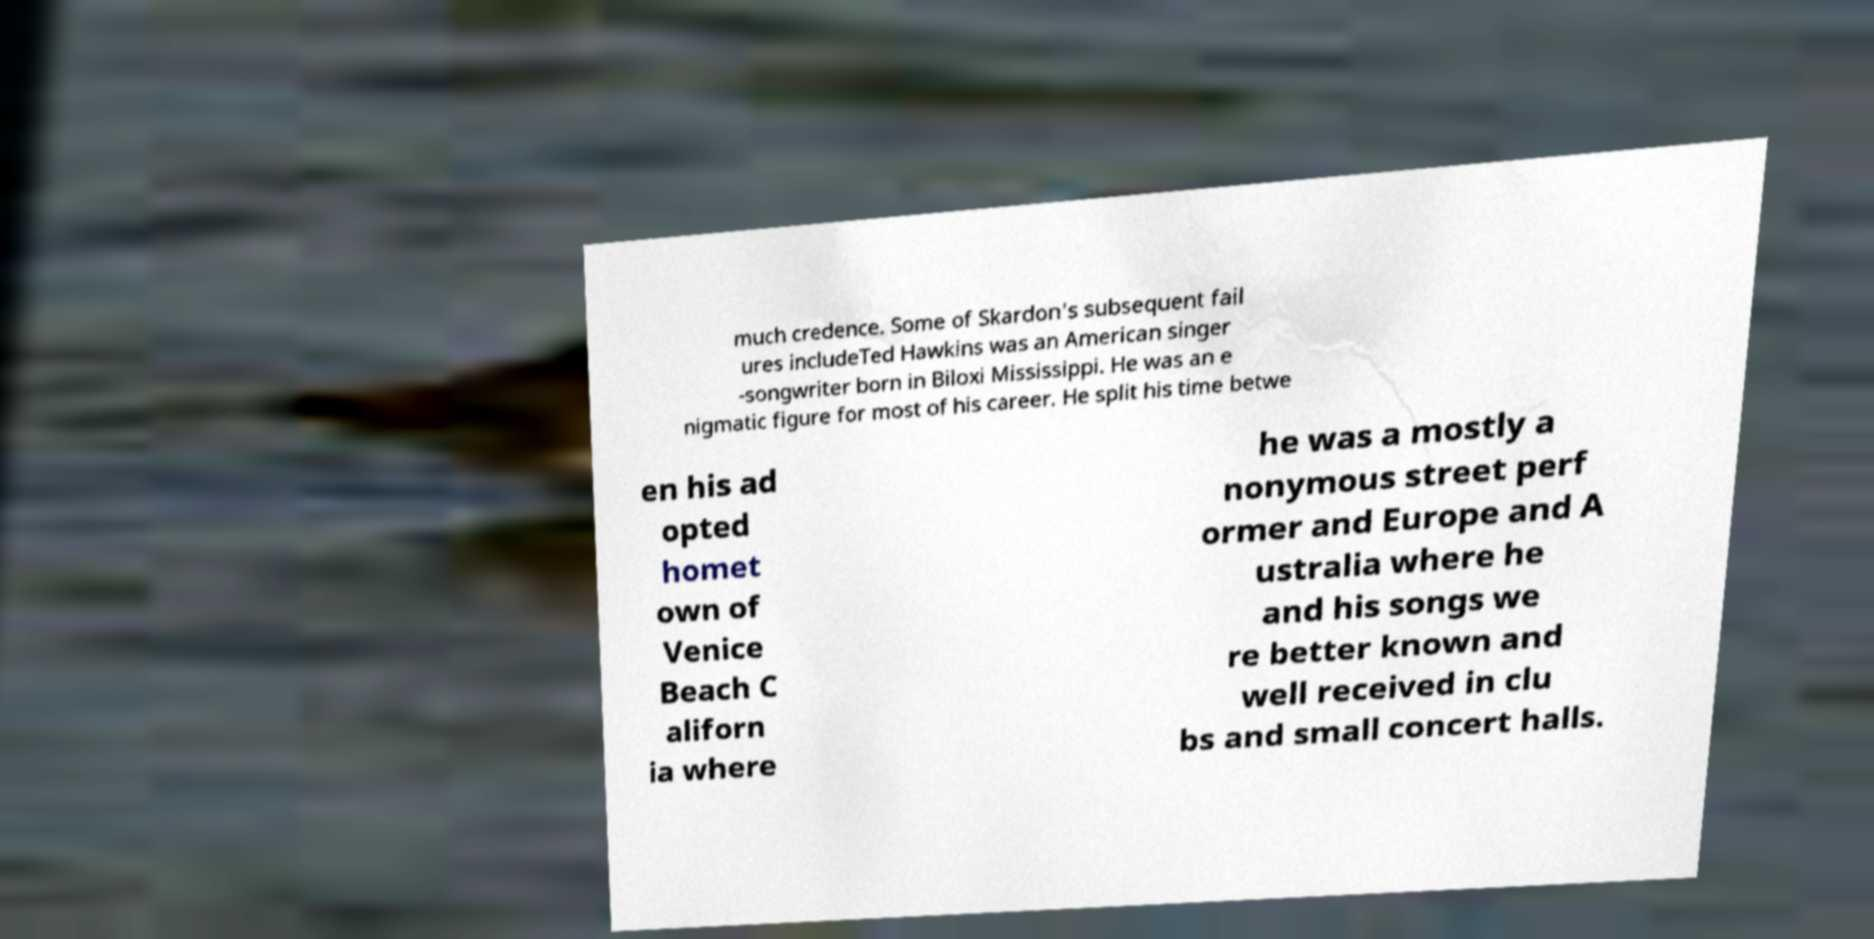Could you assist in decoding the text presented in this image and type it out clearly? much credence. Some of Skardon's subsequent fail ures includeTed Hawkins was an American singer -songwriter born in Biloxi Mississippi. He was an e nigmatic figure for most of his career. He split his time betwe en his ad opted homet own of Venice Beach C aliforn ia where he was a mostly a nonymous street perf ormer and Europe and A ustralia where he and his songs we re better known and well received in clu bs and small concert halls. 